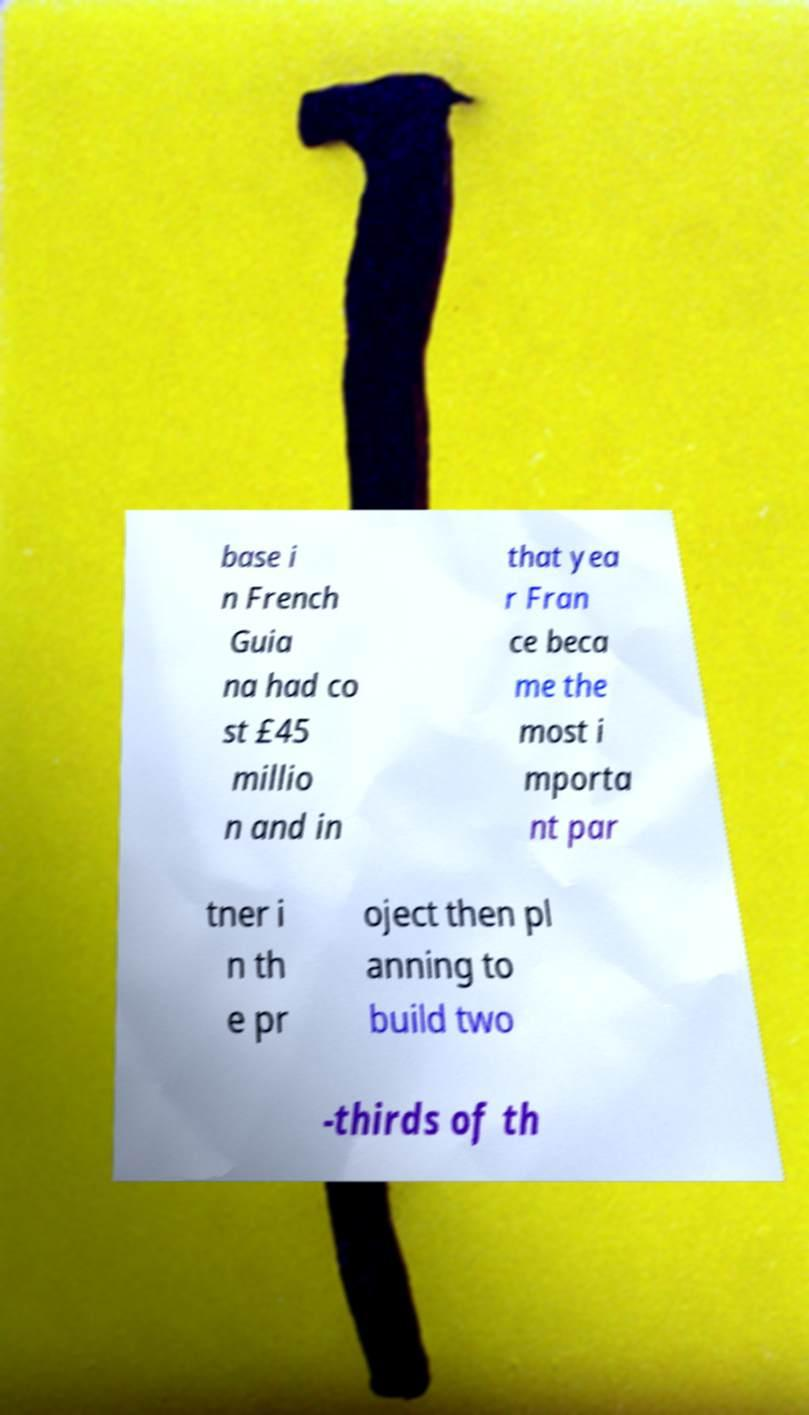Can you read and provide the text displayed in the image?This photo seems to have some interesting text. Can you extract and type it out for me? base i n French Guia na had co st £45 millio n and in that yea r Fran ce beca me the most i mporta nt par tner i n th e pr oject then pl anning to build two -thirds of th 